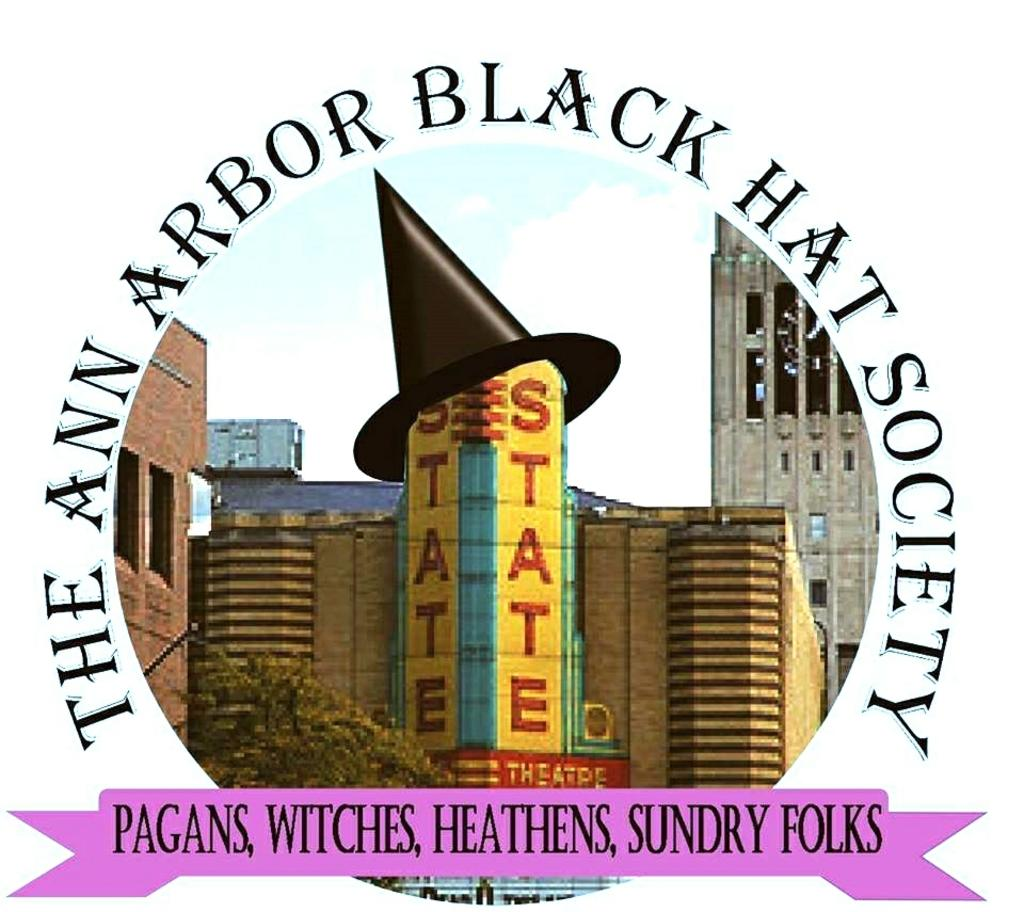What is the main subject of the poster in the image? The poster contains images of buildings and a tree. What else can be found on the poster besides the images? There is text on the poster. What type of nerve is depicted in the image? There is no nerve depicted in the image; the poster contains images of buildings and a tree, along with text. 